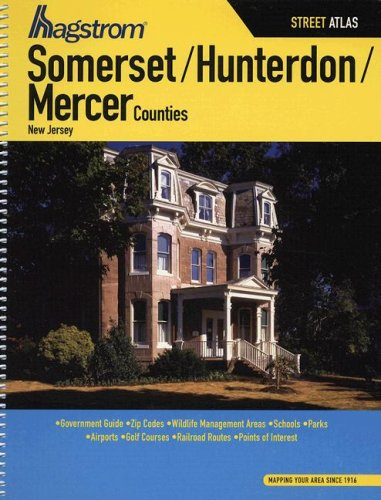What is the title of this book? The book is titled 'Hagstrom Somerset/Hunterdon/Mercer Counties, New Jersey Street Atlas'. It provides detailed street maps and points of interest for these specific counties. 